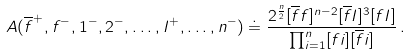Convert formula to latex. <formula><loc_0><loc_0><loc_500><loc_500>A ( \overline { f } ^ { + } , f ^ { - } , 1 ^ { - } , 2 ^ { - } , \dots , I ^ { + } , \dots , n ^ { - } ) \doteq \frac { 2 ^ { \frac { n } { 2 } } [ \overline { f } f ] ^ { n - 2 } [ \overline { f } I ] ^ { 3 } [ f I ] } { \prod _ { i = 1 } ^ { n } [ f i ] [ \overline { f } i ] } \, .</formula> 